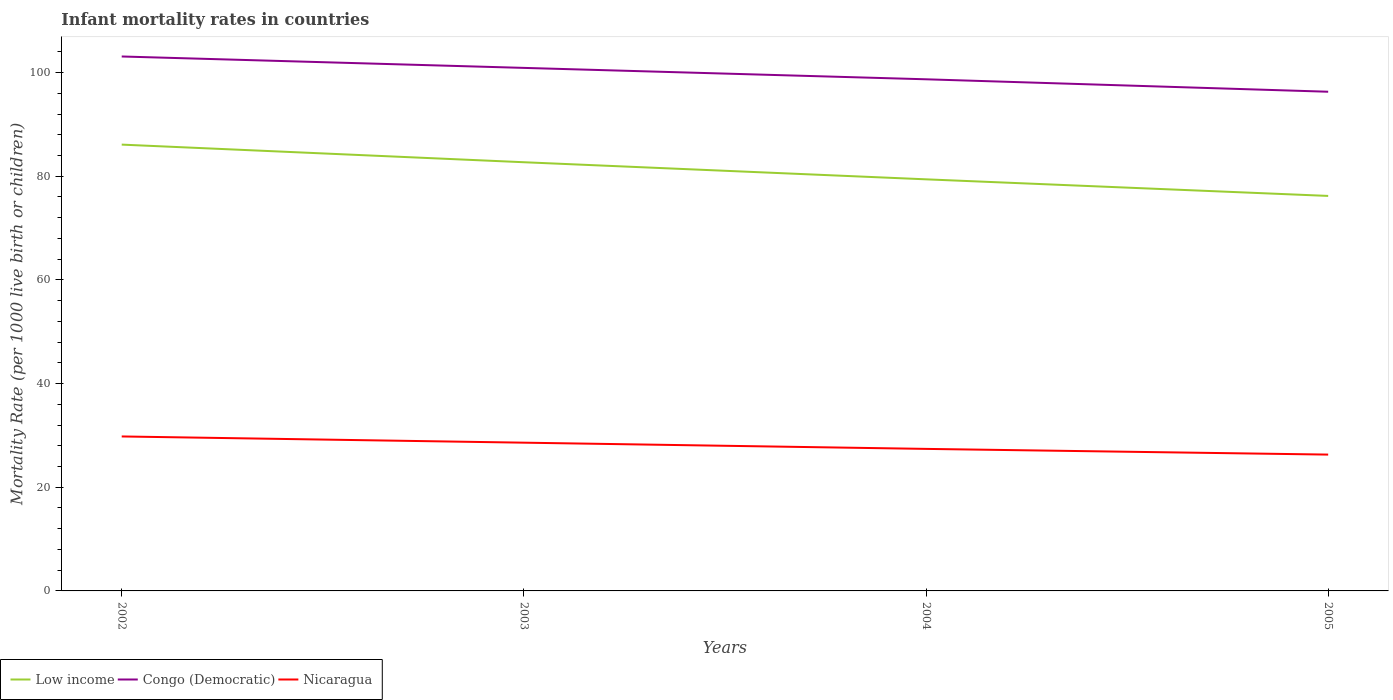How many different coloured lines are there?
Your answer should be compact. 3. Does the line corresponding to Low income intersect with the line corresponding to Congo (Democratic)?
Offer a very short reply. No. Across all years, what is the maximum infant mortality rate in Nicaragua?
Offer a very short reply. 26.3. What is the total infant mortality rate in Low income in the graph?
Provide a short and direct response. 3.4. What is the difference between the highest and the second highest infant mortality rate in Nicaragua?
Make the answer very short. 3.5. What is the difference between the highest and the lowest infant mortality rate in Congo (Democratic)?
Provide a succinct answer. 2. Are the values on the major ticks of Y-axis written in scientific E-notation?
Provide a succinct answer. No. Does the graph contain any zero values?
Your answer should be very brief. No. Where does the legend appear in the graph?
Your answer should be compact. Bottom left. How are the legend labels stacked?
Offer a very short reply. Horizontal. What is the title of the graph?
Your response must be concise. Infant mortality rates in countries. What is the label or title of the X-axis?
Provide a succinct answer. Years. What is the label or title of the Y-axis?
Ensure brevity in your answer.  Mortality Rate (per 1000 live birth or children). What is the Mortality Rate (per 1000 live birth or children) of Low income in 2002?
Your answer should be very brief. 86.1. What is the Mortality Rate (per 1000 live birth or children) of Congo (Democratic) in 2002?
Provide a succinct answer. 103.1. What is the Mortality Rate (per 1000 live birth or children) in Nicaragua in 2002?
Give a very brief answer. 29.8. What is the Mortality Rate (per 1000 live birth or children) in Low income in 2003?
Your response must be concise. 82.7. What is the Mortality Rate (per 1000 live birth or children) of Congo (Democratic) in 2003?
Provide a short and direct response. 100.9. What is the Mortality Rate (per 1000 live birth or children) in Nicaragua in 2003?
Provide a short and direct response. 28.6. What is the Mortality Rate (per 1000 live birth or children) in Low income in 2004?
Your answer should be compact. 79.4. What is the Mortality Rate (per 1000 live birth or children) of Congo (Democratic) in 2004?
Make the answer very short. 98.7. What is the Mortality Rate (per 1000 live birth or children) of Nicaragua in 2004?
Make the answer very short. 27.4. What is the Mortality Rate (per 1000 live birth or children) of Low income in 2005?
Your response must be concise. 76.2. What is the Mortality Rate (per 1000 live birth or children) in Congo (Democratic) in 2005?
Offer a very short reply. 96.3. What is the Mortality Rate (per 1000 live birth or children) of Nicaragua in 2005?
Provide a succinct answer. 26.3. Across all years, what is the maximum Mortality Rate (per 1000 live birth or children) of Low income?
Ensure brevity in your answer.  86.1. Across all years, what is the maximum Mortality Rate (per 1000 live birth or children) of Congo (Democratic)?
Your response must be concise. 103.1. Across all years, what is the maximum Mortality Rate (per 1000 live birth or children) in Nicaragua?
Ensure brevity in your answer.  29.8. Across all years, what is the minimum Mortality Rate (per 1000 live birth or children) of Low income?
Make the answer very short. 76.2. Across all years, what is the minimum Mortality Rate (per 1000 live birth or children) in Congo (Democratic)?
Ensure brevity in your answer.  96.3. Across all years, what is the minimum Mortality Rate (per 1000 live birth or children) of Nicaragua?
Your response must be concise. 26.3. What is the total Mortality Rate (per 1000 live birth or children) in Low income in the graph?
Provide a short and direct response. 324.4. What is the total Mortality Rate (per 1000 live birth or children) of Congo (Democratic) in the graph?
Your answer should be very brief. 399. What is the total Mortality Rate (per 1000 live birth or children) of Nicaragua in the graph?
Provide a succinct answer. 112.1. What is the difference between the Mortality Rate (per 1000 live birth or children) of Congo (Democratic) in 2002 and that in 2003?
Your answer should be very brief. 2.2. What is the difference between the Mortality Rate (per 1000 live birth or children) in Nicaragua in 2002 and that in 2003?
Provide a succinct answer. 1.2. What is the difference between the Mortality Rate (per 1000 live birth or children) in Low income in 2002 and that in 2004?
Provide a short and direct response. 6.7. What is the difference between the Mortality Rate (per 1000 live birth or children) of Congo (Democratic) in 2002 and that in 2004?
Offer a terse response. 4.4. What is the difference between the Mortality Rate (per 1000 live birth or children) in Nicaragua in 2002 and that in 2004?
Your response must be concise. 2.4. What is the difference between the Mortality Rate (per 1000 live birth or children) in Congo (Democratic) in 2002 and that in 2005?
Provide a succinct answer. 6.8. What is the difference between the Mortality Rate (per 1000 live birth or children) of Nicaragua in 2003 and that in 2004?
Make the answer very short. 1.2. What is the difference between the Mortality Rate (per 1000 live birth or children) of Congo (Democratic) in 2003 and that in 2005?
Offer a terse response. 4.6. What is the difference between the Mortality Rate (per 1000 live birth or children) in Nicaragua in 2003 and that in 2005?
Offer a very short reply. 2.3. What is the difference between the Mortality Rate (per 1000 live birth or children) of Congo (Democratic) in 2004 and that in 2005?
Offer a terse response. 2.4. What is the difference between the Mortality Rate (per 1000 live birth or children) in Low income in 2002 and the Mortality Rate (per 1000 live birth or children) in Congo (Democratic) in 2003?
Your answer should be very brief. -14.8. What is the difference between the Mortality Rate (per 1000 live birth or children) in Low income in 2002 and the Mortality Rate (per 1000 live birth or children) in Nicaragua in 2003?
Your answer should be very brief. 57.5. What is the difference between the Mortality Rate (per 1000 live birth or children) of Congo (Democratic) in 2002 and the Mortality Rate (per 1000 live birth or children) of Nicaragua in 2003?
Your answer should be compact. 74.5. What is the difference between the Mortality Rate (per 1000 live birth or children) of Low income in 2002 and the Mortality Rate (per 1000 live birth or children) of Congo (Democratic) in 2004?
Your answer should be compact. -12.6. What is the difference between the Mortality Rate (per 1000 live birth or children) of Low income in 2002 and the Mortality Rate (per 1000 live birth or children) of Nicaragua in 2004?
Ensure brevity in your answer.  58.7. What is the difference between the Mortality Rate (per 1000 live birth or children) in Congo (Democratic) in 2002 and the Mortality Rate (per 1000 live birth or children) in Nicaragua in 2004?
Your response must be concise. 75.7. What is the difference between the Mortality Rate (per 1000 live birth or children) in Low income in 2002 and the Mortality Rate (per 1000 live birth or children) in Congo (Democratic) in 2005?
Your response must be concise. -10.2. What is the difference between the Mortality Rate (per 1000 live birth or children) in Low income in 2002 and the Mortality Rate (per 1000 live birth or children) in Nicaragua in 2005?
Make the answer very short. 59.8. What is the difference between the Mortality Rate (per 1000 live birth or children) of Congo (Democratic) in 2002 and the Mortality Rate (per 1000 live birth or children) of Nicaragua in 2005?
Make the answer very short. 76.8. What is the difference between the Mortality Rate (per 1000 live birth or children) of Low income in 2003 and the Mortality Rate (per 1000 live birth or children) of Nicaragua in 2004?
Offer a terse response. 55.3. What is the difference between the Mortality Rate (per 1000 live birth or children) of Congo (Democratic) in 2003 and the Mortality Rate (per 1000 live birth or children) of Nicaragua in 2004?
Your answer should be compact. 73.5. What is the difference between the Mortality Rate (per 1000 live birth or children) in Low income in 2003 and the Mortality Rate (per 1000 live birth or children) in Nicaragua in 2005?
Provide a short and direct response. 56.4. What is the difference between the Mortality Rate (per 1000 live birth or children) in Congo (Democratic) in 2003 and the Mortality Rate (per 1000 live birth or children) in Nicaragua in 2005?
Your answer should be very brief. 74.6. What is the difference between the Mortality Rate (per 1000 live birth or children) of Low income in 2004 and the Mortality Rate (per 1000 live birth or children) of Congo (Democratic) in 2005?
Provide a succinct answer. -16.9. What is the difference between the Mortality Rate (per 1000 live birth or children) of Low income in 2004 and the Mortality Rate (per 1000 live birth or children) of Nicaragua in 2005?
Give a very brief answer. 53.1. What is the difference between the Mortality Rate (per 1000 live birth or children) in Congo (Democratic) in 2004 and the Mortality Rate (per 1000 live birth or children) in Nicaragua in 2005?
Your response must be concise. 72.4. What is the average Mortality Rate (per 1000 live birth or children) of Low income per year?
Offer a very short reply. 81.1. What is the average Mortality Rate (per 1000 live birth or children) of Congo (Democratic) per year?
Your answer should be very brief. 99.75. What is the average Mortality Rate (per 1000 live birth or children) of Nicaragua per year?
Ensure brevity in your answer.  28.02. In the year 2002, what is the difference between the Mortality Rate (per 1000 live birth or children) of Low income and Mortality Rate (per 1000 live birth or children) of Congo (Democratic)?
Offer a terse response. -17. In the year 2002, what is the difference between the Mortality Rate (per 1000 live birth or children) of Low income and Mortality Rate (per 1000 live birth or children) of Nicaragua?
Your answer should be very brief. 56.3. In the year 2002, what is the difference between the Mortality Rate (per 1000 live birth or children) in Congo (Democratic) and Mortality Rate (per 1000 live birth or children) in Nicaragua?
Your answer should be very brief. 73.3. In the year 2003, what is the difference between the Mortality Rate (per 1000 live birth or children) of Low income and Mortality Rate (per 1000 live birth or children) of Congo (Democratic)?
Offer a terse response. -18.2. In the year 2003, what is the difference between the Mortality Rate (per 1000 live birth or children) in Low income and Mortality Rate (per 1000 live birth or children) in Nicaragua?
Your answer should be compact. 54.1. In the year 2003, what is the difference between the Mortality Rate (per 1000 live birth or children) of Congo (Democratic) and Mortality Rate (per 1000 live birth or children) of Nicaragua?
Your response must be concise. 72.3. In the year 2004, what is the difference between the Mortality Rate (per 1000 live birth or children) of Low income and Mortality Rate (per 1000 live birth or children) of Congo (Democratic)?
Ensure brevity in your answer.  -19.3. In the year 2004, what is the difference between the Mortality Rate (per 1000 live birth or children) of Congo (Democratic) and Mortality Rate (per 1000 live birth or children) of Nicaragua?
Make the answer very short. 71.3. In the year 2005, what is the difference between the Mortality Rate (per 1000 live birth or children) of Low income and Mortality Rate (per 1000 live birth or children) of Congo (Democratic)?
Make the answer very short. -20.1. In the year 2005, what is the difference between the Mortality Rate (per 1000 live birth or children) in Low income and Mortality Rate (per 1000 live birth or children) in Nicaragua?
Offer a terse response. 49.9. What is the ratio of the Mortality Rate (per 1000 live birth or children) in Low income in 2002 to that in 2003?
Make the answer very short. 1.04. What is the ratio of the Mortality Rate (per 1000 live birth or children) in Congo (Democratic) in 2002 to that in 2003?
Offer a terse response. 1.02. What is the ratio of the Mortality Rate (per 1000 live birth or children) in Nicaragua in 2002 to that in 2003?
Your answer should be very brief. 1.04. What is the ratio of the Mortality Rate (per 1000 live birth or children) of Low income in 2002 to that in 2004?
Offer a terse response. 1.08. What is the ratio of the Mortality Rate (per 1000 live birth or children) of Congo (Democratic) in 2002 to that in 2004?
Your answer should be very brief. 1.04. What is the ratio of the Mortality Rate (per 1000 live birth or children) in Nicaragua in 2002 to that in 2004?
Your response must be concise. 1.09. What is the ratio of the Mortality Rate (per 1000 live birth or children) in Low income in 2002 to that in 2005?
Give a very brief answer. 1.13. What is the ratio of the Mortality Rate (per 1000 live birth or children) in Congo (Democratic) in 2002 to that in 2005?
Your response must be concise. 1.07. What is the ratio of the Mortality Rate (per 1000 live birth or children) in Nicaragua in 2002 to that in 2005?
Offer a terse response. 1.13. What is the ratio of the Mortality Rate (per 1000 live birth or children) of Low income in 2003 to that in 2004?
Offer a very short reply. 1.04. What is the ratio of the Mortality Rate (per 1000 live birth or children) in Congo (Democratic) in 2003 to that in 2004?
Offer a terse response. 1.02. What is the ratio of the Mortality Rate (per 1000 live birth or children) of Nicaragua in 2003 to that in 2004?
Give a very brief answer. 1.04. What is the ratio of the Mortality Rate (per 1000 live birth or children) of Low income in 2003 to that in 2005?
Ensure brevity in your answer.  1.09. What is the ratio of the Mortality Rate (per 1000 live birth or children) of Congo (Democratic) in 2003 to that in 2005?
Provide a succinct answer. 1.05. What is the ratio of the Mortality Rate (per 1000 live birth or children) of Nicaragua in 2003 to that in 2005?
Make the answer very short. 1.09. What is the ratio of the Mortality Rate (per 1000 live birth or children) in Low income in 2004 to that in 2005?
Provide a short and direct response. 1.04. What is the ratio of the Mortality Rate (per 1000 live birth or children) in Congo (Democratic) in 2004 to that in 2005?
Ensure brevity in your answer.  1.02. What is the ratio of the Mortality Rate (per 1000 live birth or children) of Nicaragua in 2004 to that in 2005?
Offer a very short reply. 1.04. What is the difference between the highest and the second highest Mortality Rate (per 1000 live birth or children) in Low income?
Give a very brief answer. 3.4. What is the difference between the highest and the lowest Mortality Rate (per 1000 live birth or children) in Low income?
Offer a very short reply. 9.9. What is the difference between the highest and the lowest Mortality Rate (per 1000 live birth or children) in Congo (Democratic)?
Your response must be concise. 6.8. What is the difference between the highest and the lowest Mortality Rate (per 1000 live birth or children) in Nicaragua?
Your answer should be compact. 3.5. 